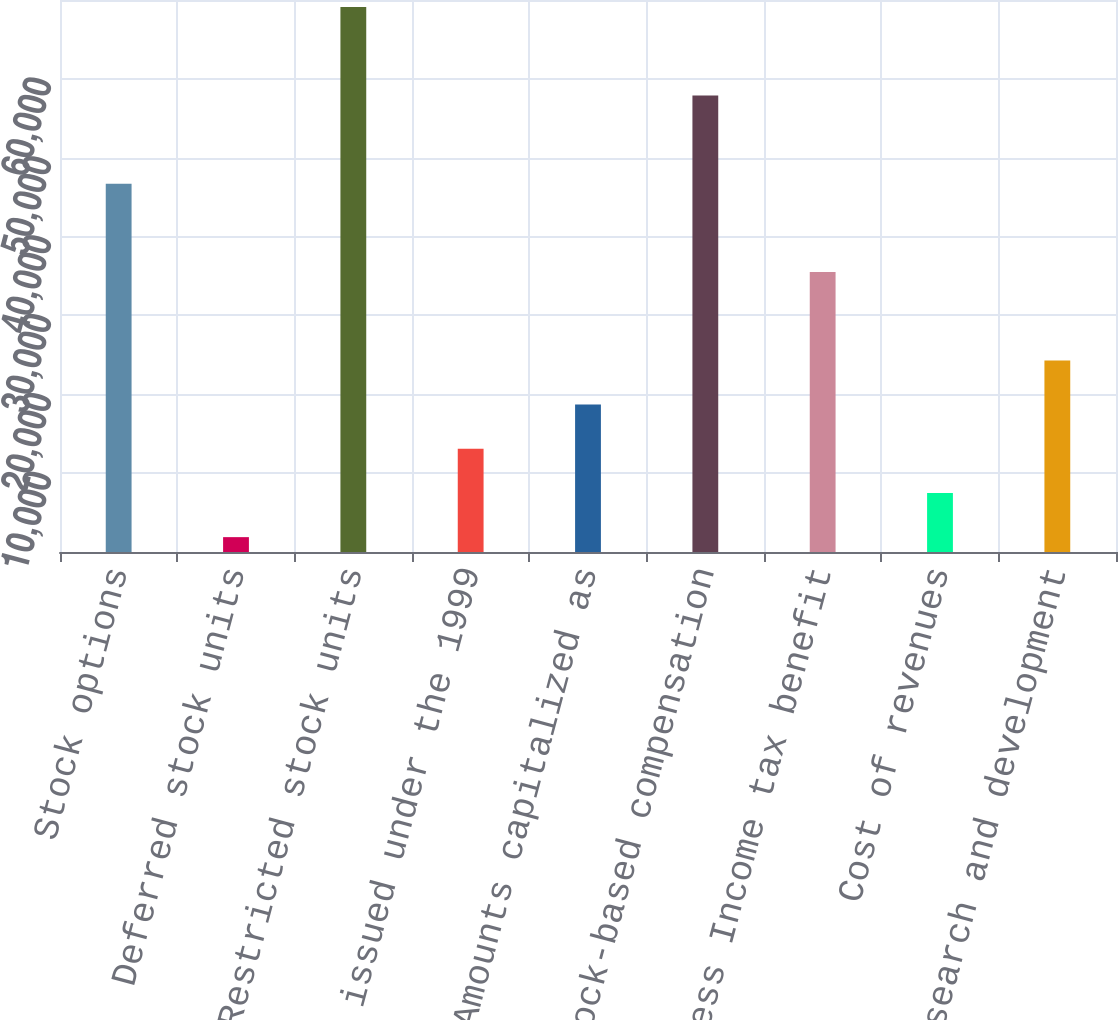Convert chart. <chart><loc_0><loc_0><loc_500><loc_500><bar_chart><fcel>Stock options<fcel>Deferred stock units<fcel>Restricted stock units<fcel>Shares issued under the 1999<fcel>Amounts capitalized as<fcel>Total stock-based compensation<fcel>Less Income tax benefit<fcel>Cost of revenues<fcel>Research and development<nl><fcel>46696.2<fcel>1885<fcel>69101.8<fcel>13087.8<fcel>18689.2<fcel>57899<fcel>35493.4<fcel>7486.4<fcel>24290.6<nl></chart> 